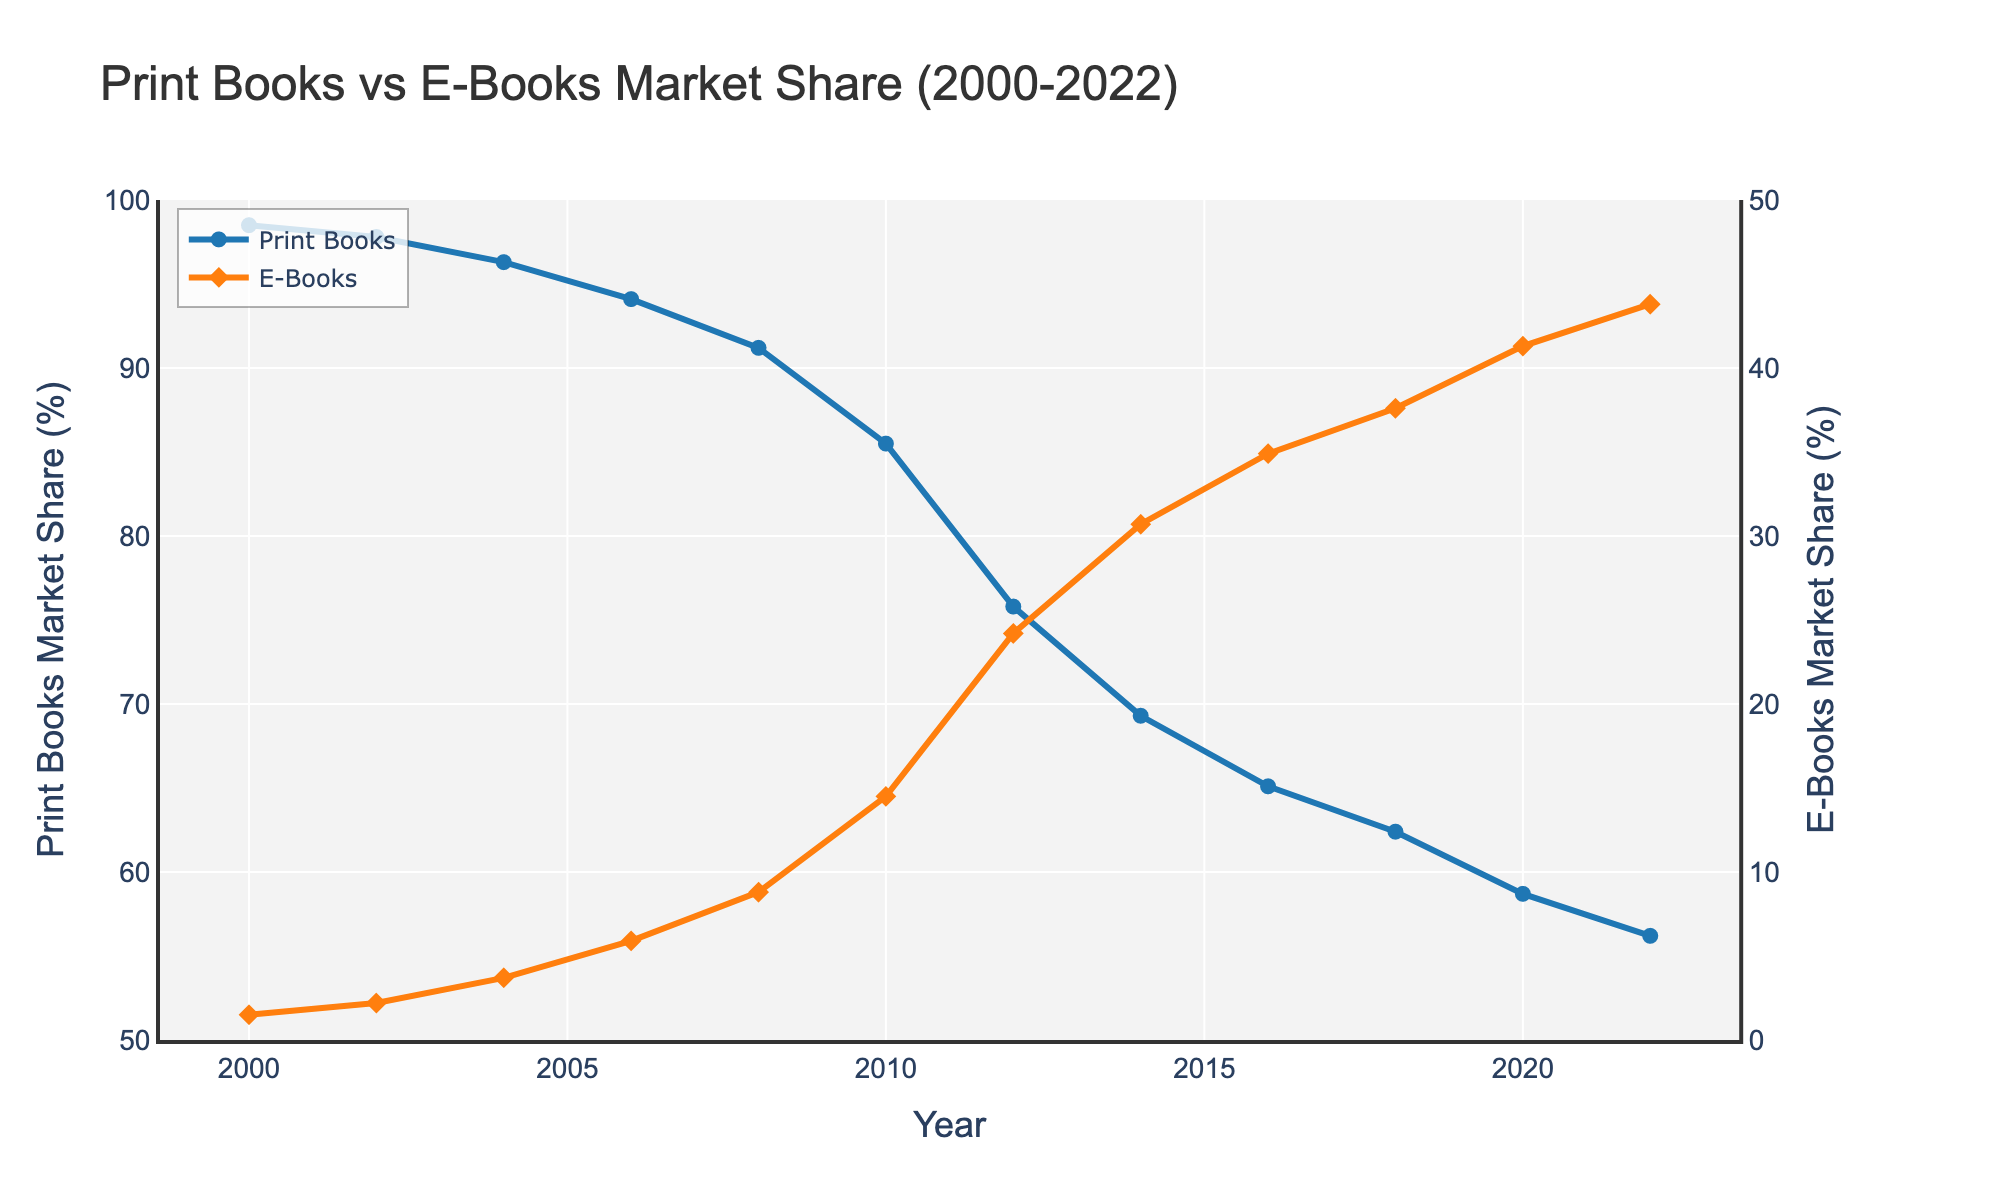What year did e-books first have more than 10% market share? Look for the year where the E-Books Market Share (%) first exceeds 10%. In 2010, e-books had a market share of 14.5%.
Answer: 2010 How much did the print book market share decrease from 2000 to 2012? Subtract the 2012 value from the 2000 value for Print Books Market Share (%). 98.5% - 75.8% = 22.7%
Answer: 22.7% In 2022, how did the market shares of print books and e-books compare? Check the 2022 values for both Print Books and E-Books Market Share (%). Print books had a market share of 56.2%, and e-books had 43.8%.
Answer: Print: 56.2%, E-books: 43.8% Which type of book reached a market share above 40% first, and in what year? Identify the first year either book type reaches more than 40%. E-books did so in 2020 with 41.3%.
Answer: E-books, 2020 What is the trend in market share for print books from 2000 to 2022? Observe the line for Print Books Market Share (%) from start to end. The trend shows a steady decline from 98.5% in 2000 to 56.2% in 2022.
Answer: Steady decline What is the average annual market share of e-books between 2008 and 2022? Add up the E-Books Market Share (%) values from 2008 to 2022 and divide by the number of years (8 values). (8.8 + 14.5 + 24.2 + 30.7 + 34.9 + 37.6 + 41.3 + 43.8) / 8 = 29.5%
Answer: 29.5% By how many percentage points did e-books' market share increase between 2006 and 2014? Subtract the 2006 value for e-books from the 2014 value. 30.7% - 5.9% = 24.8%
Answer: 24.8% In which year was the gap between print books and e-books market share the largest, and what was the gap? Calculate the differences for each year and find the maximum. The largest gap was in 2000: 98.5% - 1.5% = 97%.
Answer: 2000, 97% What is the median market share of print books for the years given? Arrange the Print Books Market Share (%) values in order and find the middle value. The ordered values are: [56.2, 58.7, 62.4, 65.1, 69.3, 75.8, 85.5, 91.2, 94.1, 96.3, 97.8, 98.5]. The median is the average of the 6th and 7th values: (75.8 + 85.5) / 2 = 80.65
Answer: 80.65% 